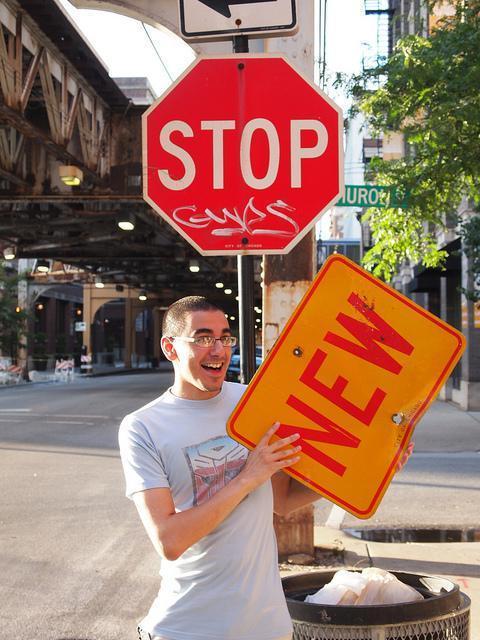How many boats are in front of the church?
Give a very brief answer. 0. 